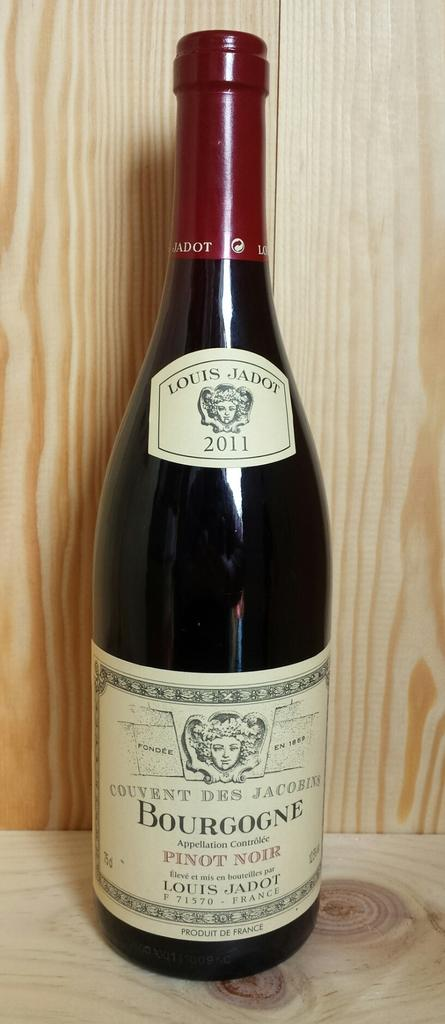What is the main object in the image? There is a wine bottle in the image. Can you describe any specific details about the wine bottle? There is writing on the wine bottle. How many chickens are sitting in the pocket of the wine bottle in the image? There are no chickens present in the image, and the wine bottle does not have a pocket. 